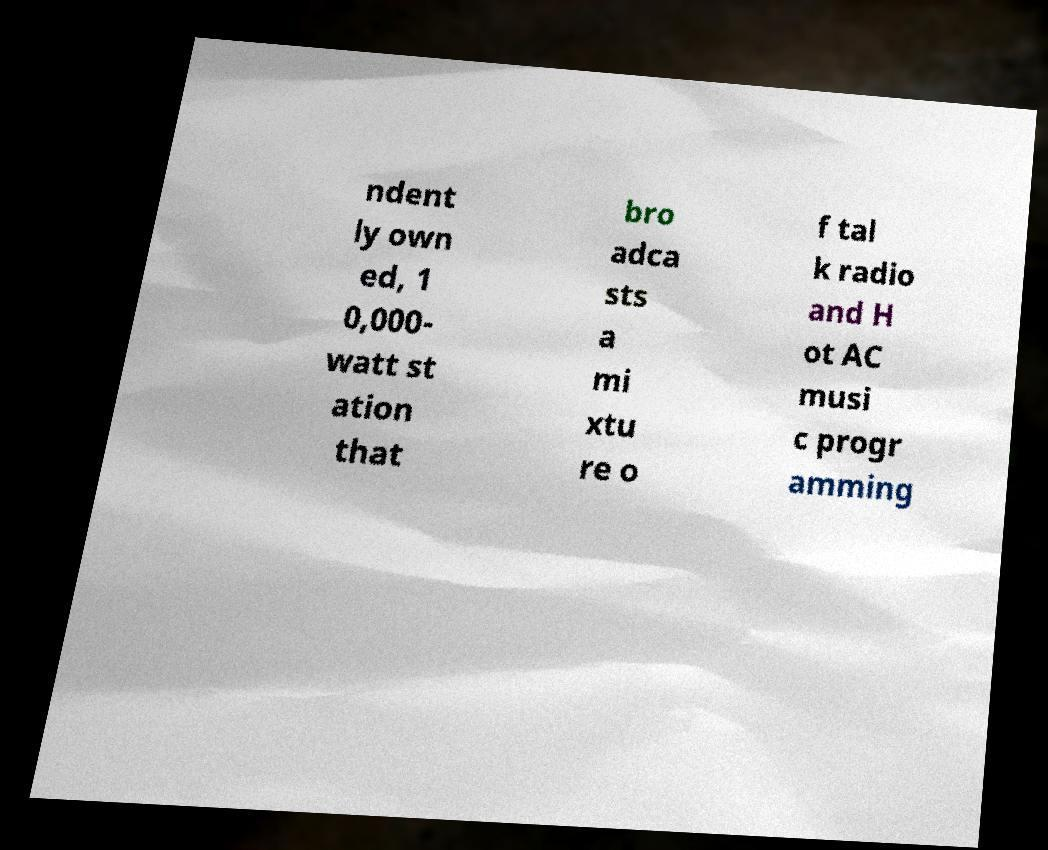Can you read and provide the text displayed in the image?This photo seems to have some interesting text. Can you extract and type it out for me? ndent ly own ed, 1 0,000- watt st ation that bro adca sts a mi xtu re o f tal k radio and H ot AC musi c progr amming 